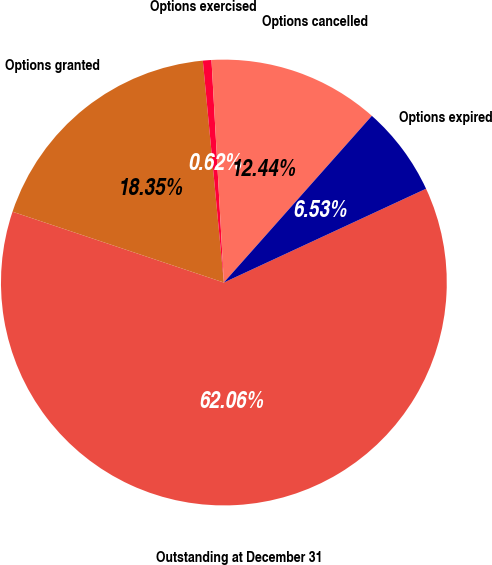Convert chart. <chart><loc_0><loc_0><loc_500><loc_500><pie_chart><fcel>Outstanding at December 31<fcel>Options granted<fcel>Options exercised<fcel>Options cancelled<fcel>Options expired<nl><fcel>62.06%<fcel>18.35%<fcel>0.62%<fcel>12.44%<fcel>6.53%<nl></chart> 